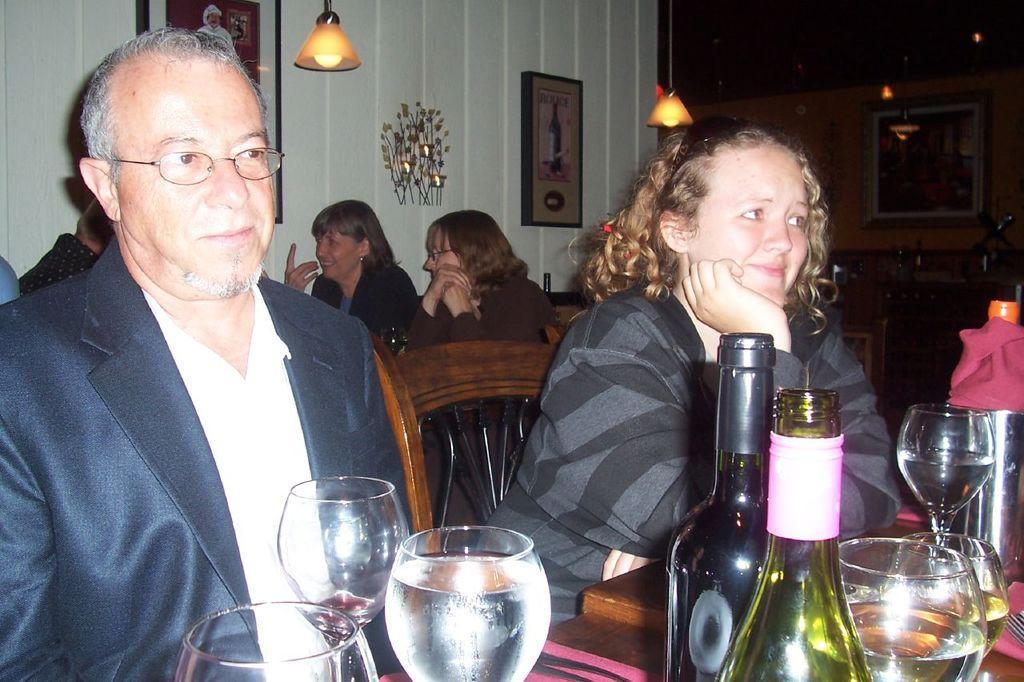Could you give a brief overview of what you see in this image? In this picture we have two people sitting on the chair in front of the table where we have some glasses and bottles. Behind them there are two people sitting on the chairs and to the wall there are some photo frames and a lamp. 